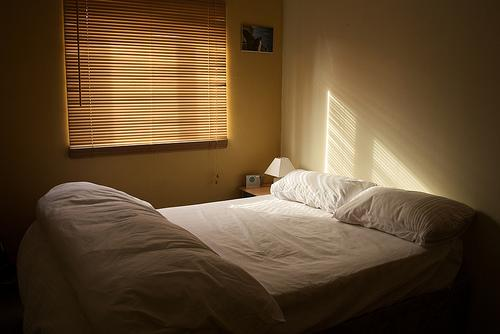Question: when was the picture taken?
Choices:
A. Night.
B. Morning.
C. Evening.
D. During the day.
Answer with the letter. Answer: D Question: who is in the bed?
Choices:
A. A woman.
B. A child.
C. A man and a woman.
D. No one.
Answer with the letter. Answer: D Question: how many pillows are on the bed?
Choices:
A. 12.
B. 13.
C. 2.
D. 5.
Answer with the letter. Answer: C Question: where was the picture taken?
Choices:
A. In a hotel room.
B. In the living room.
C. In a child's room.
D. In a bedroom.
Answer with the letter. Answer: D Question: what is up to the window?
Choices:
A. Curtains.
B. Thermometer.
C. Stained glass.
D. Blinds.
Answer with the letter. Answer: D 